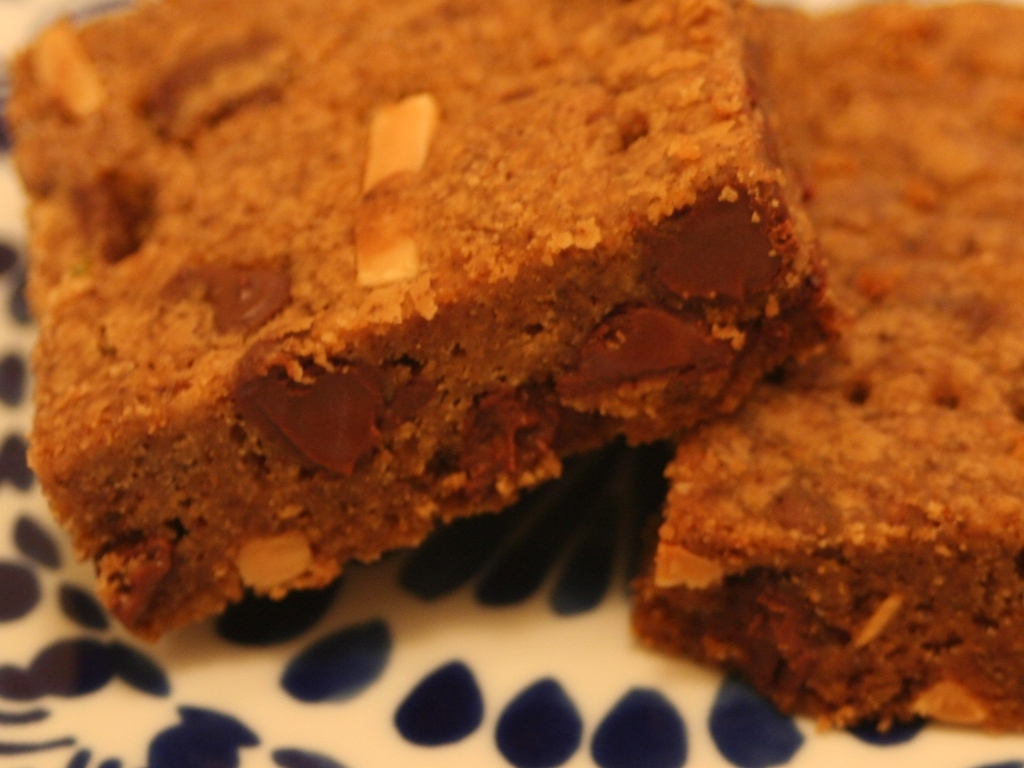Can you tell something about the presentation style of these brownies? Of course! The brownies are neatly cut into squares and arranged slightly overlapping on a decorative plate with a blue floral pattern, which contrasts the rich brown color of the brownies. The presentation is simple yet appealing, with a homestyle feel that suggests these treats are ready to be served at a casual gathering or enjoyed as a personal indulgence. Do these brownies have any toppings or frosting? No, there appears to be no toppings or frosting on these brownies. Their simplicity highlights the classic flavor and texture of a traditional brownie, allowing the chocolate chunks to be the focal point of enjoyment. 